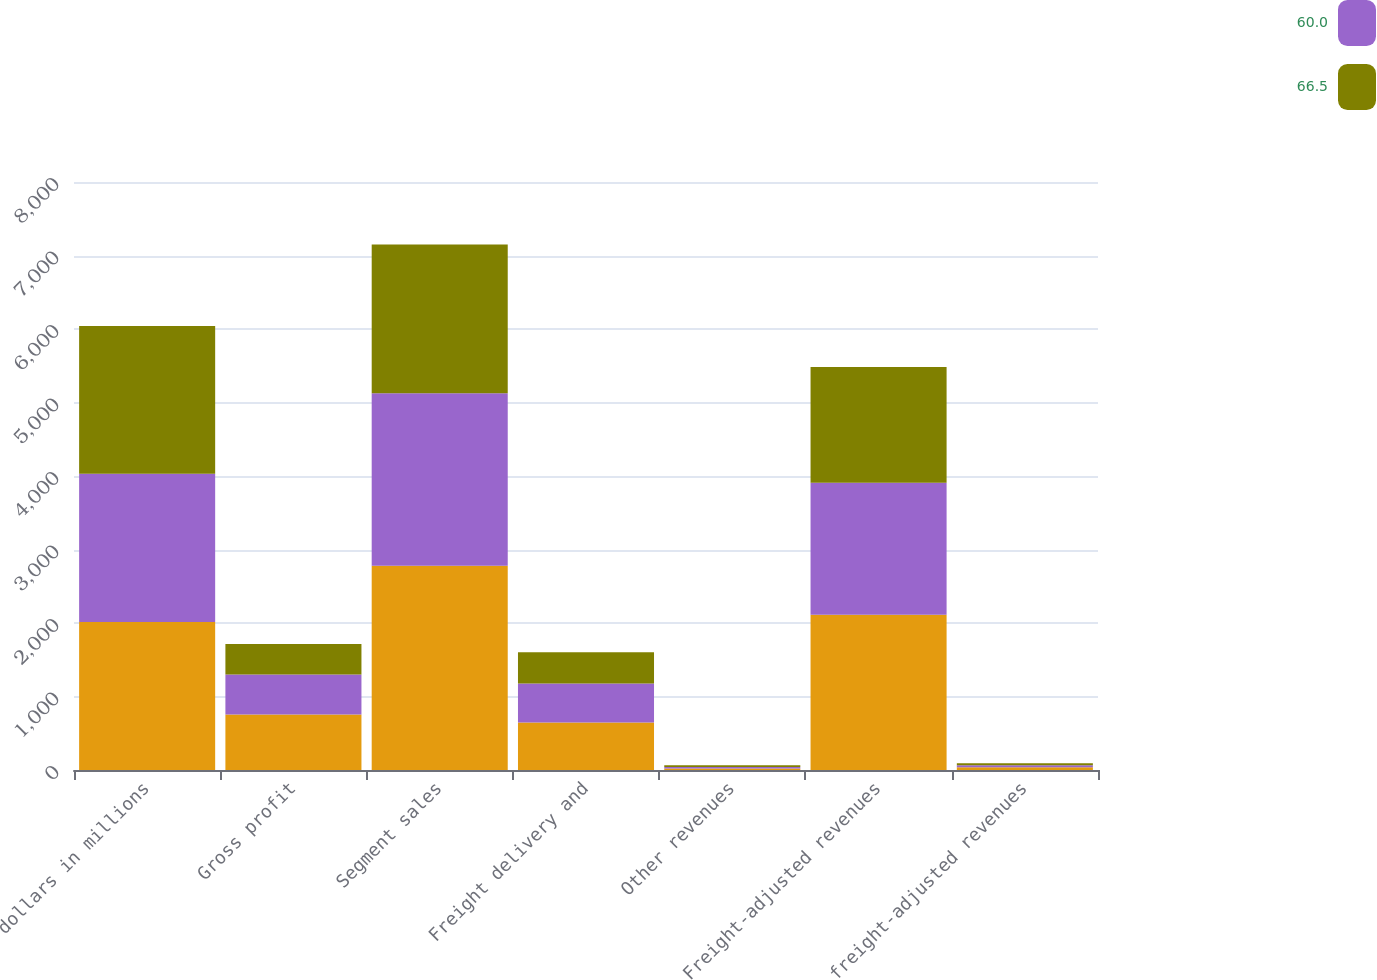<chart> <loc_0><loc_0><loc_500><loc_500><stacked_bar_chart><ecel><fcel>dollars in millions<fcel>Gross profit<fcel>Segment sales<fcel>Freight delivery and<fcel>Other revenues<fcel>Freight-adjusted revenues<fcel>freight-adjusted revenues<nl><fcel>nan<fcel>2015<fcel>755.7<fcel>2777.8<fcel>644.7<fcel>20.6<fcel>2112.5<fcel>35.8<nl><fcel>60<fcel>2014<fcel>544.1<fcel>2346.4<fcel>532.2<fcel>20.2<fcel>1794<fcel>30.3<nl><fcel>66.5<fcel>2013<fcel>413.3<fcel>2025<fcel>424.9<fcel>24.1<fcel>1576<fcel>26.2<nl></chart> 